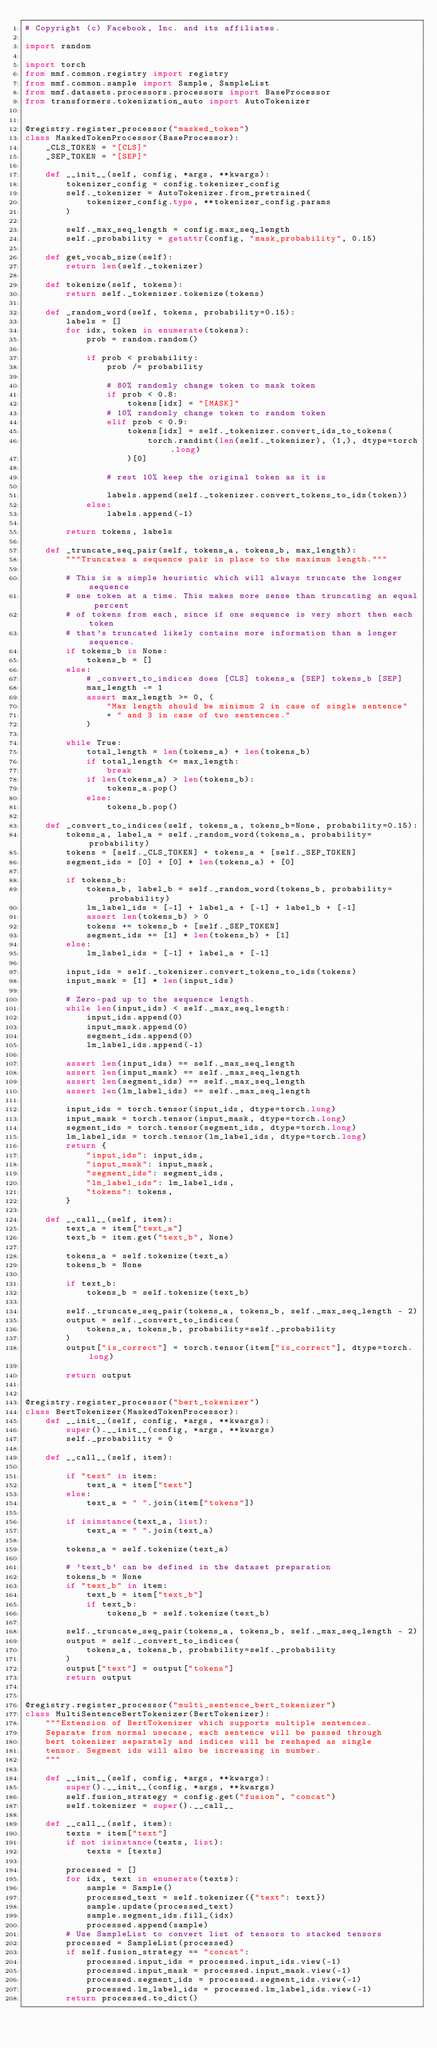<code> <loc_0><loc_0><loc_500><loc_500><_Python_># Copyright (c) Facebook, Inc. and its affiliates.

import random

import torch
from mmf.common.registry import registry
from mmf.common.sample import Sample, SampleList
from mmf.datasets.processors.processors import BaseProcessor
from transformers.tokenization_auto import AutoTokenizer


@registry.register_processor("masked_token")
class MaskedTokenProcessor(BaseProcessor):
    _CLS_TOKEN = "[CLS]"
    _SEP_TOKEN = "[SEP]"

    def __init__(self, config, *args, **kwargs):
        tokenizer_config = config.tokenizer_config
        self._tokenizer = AutoTokenizer.from_pretrained(
            tokenizer_config.type, **tokenizer_config.params
        )

        self._max_seq_length = config.max_seq_length
        self._probability = getattr(config, "mask_probability", 0.15)

    def get_vocab_size(self):
        return len(self._tokenizer)

    def tokenize(self, tokens):
        return self._tokenizer.tokenize(tokens)

    def _random_word(self, tokens, probability=0.15):
        labels = []
        for idx, token in enumerate(tokens):
            prob = random.random()

            if prob < probability:
                prob /= probability

                # 80% randomly change token to mask token
                if prob < 0.8:
                    tokens[idx] = "[MASK]"
                # 10% randomly change token to random token
                elif prob < 0.9:
                    tokens[idx] = self._tokenizer.convert_ids_to_tokens(
                        torch.randint(len(self._tokenizer), (1,), dtype=torch.long)
                    )[0]

                # rest 10% keep the original token as it is

                labels.append(self._tokenizer.convert_tokens_to_ids(token))
            else:
                labels.append(-1)

        return tokens, labels

    def _truncate_seq_pair(self, tokens_a, tokens_b, max_length):
        """Truncates a sequence pair in place to the maximum length."""

        # This is a simple heuristic which will always truncate the longer sequence
        # one token at a time. This makes more sense than truncating an equal percent
        # of tokens from each, since if one sequence is very short then each token
        # that's truncated likely contains more information than a longer sequence.
        if tokens_b is None:
            tokens_b = []
        else:
            # _convert_to_indices does [CLS] tokens_a [SEP] tokens_b [SEP]
            max_length -= 1
            assert max_length >= 0, (
                "Max length should be minimum 2 in case of single sentence"
                + " and 3 in case of two sentences."
            )

        while True:
            total_length = len(tokens_a) + len(tokens_b)
            if total_length <= max_length:
                break
            if len(tokens_a) > len(tokens_b):
                tokens_a.pop()
            else:
                tokens_b.pop()

    def _convert_to_indices(self, tokens_a, tokens_b=None, probability=0.15):
        tokens_a, label_a = self._random_word(tokens_a, probability=probability)
        tokens = [self._CLS_TOKEN] + tokens_a + [self._SEP_TOKEN]
        segment_ids = [0] + [0] * len(tokens_a) + [0]

        if tokens_b:
            tokens_b, label_b = self._random_word(tokens_b, probability=probability)
            lm_label_ids = [-1] + label_a + [-1] + label_b + [-1]
            assert len(tokens_b) > 0
            tokens += tokens_b + [self._SEP_TOKEN]
            segment_ids += [1] * len(tokens_b) + [1]
        else:
            lm_label_ids = [-1] + label_a + [-1]

        input_ids = self._tokenizer.convert_tokens_to_ids(tokens)
        input_mask = [1] * len(input_ids)

        # Zero-pad up to the sequence length.
        while len(input_ids) < self._max_seq_length:
            input_ids.append(0)
            input_mask.append(0)
            segment_ids.append(0)
            lm_label_ids.append(-1)

        assert len(input_ids) == self._max_seq_length
        assert len(input_mask) == self._max_seq_length
        assert len(segment_ids) == self._max_seq_length
        assert len(lm_label_ids) == self._max_seq_length

        input_ids = torch.tensor(input_ids, dtype=torch.long)
        input_mask = torch.tensor(input_mask, dtype=torch.long)
        segment_ids = torch.tensor(segment_ids, dtype=torch.long)
        lm_label_ids = torch.tensor(lm_label_ids, dtype=torch.long)
        return {
            "input_ids": input_ids,
            "input_mask": input_mask,
            "segment_ids": segment_ids,
            "lm_label_ids": lm_label_ids,
            "tokens": tokens,
        }

    def __call__(self, item):
        text_a = item["text_a"]
        text_b = item.get("text_b", None)

        tokens_a = self.tokenize(text_a)
        tokens_b = None

        if text_b:
            tokens_b = self.tokenize(text_b)

        self._truncate_seq_pair(tokens_a, tokens_b, self._max_seq_length - 2)
        output = self._convert_to_indices(
            tokens_a, tokens_b, probability=self._probability
        )
        output["is_correct"] = torch.tensor(item["is_correct"], dtype=torch.long)

        return output


@registry.register_processor("bert_tokenizer")
class BertTokenizer(MaskedTokenProcessor):
    def __init__(self, config, *args, **kwargs):
        super().__init__(config, *args, **kwargs)
        self._probability = 0

    def __call__(self, item):

        if "text" in item:
            text_a = item["text"]
        else:
            text_a = " ".join(item["tokens"])

        if isinstance(text_a, list):
            text_a = " ".join(text_a)

        tokens_a = self.tokenize(text_a)

        # 'text_b' can be defined in the dataset preparation
        tokens_b = None
        if "text_b" in item:
            text_b = item["text_b"]
            if text_b:
                tokens_b = self.tokenize(text_b)

        self._truncate_seq_pair(tokens_a, tokens_b, self._max_seq_length - 2)
        output = self._convert_to_indices(
            tokens_a, tokens_b, probability=self._probability
        )
        output["text"] = output["tokens"]
        return output


@registry.register_processor("multi_sentence_bert_tokenizer")
class MultiSentenceBertTokenizer(BertTokenizer):
    """Extension of BertTokenizer which supports multiple sentences.
    Separate from normal usecase, each sentence will be passed through
    bert tokenizer separately and indices will be reshaped as single
    tensor. Segment ids will also be increasing in number.
    """

    def __init__(self, config, *args, **kwargs):
        super().__init__(config, *args, **kwargs)
        self.fusion_strategy = config.get("fusion", "concat")
        self.tokenizer = super().__call__

    def __call__(self, item):
        texts = item["text"]
        if not isinstance(texts, list):
            texts = [texts]

        processed = []
        for idx, text in enumerate(texts):
            sample = Sample()
            processed_text = self.tokenizer({"text": text})
            sample.update(processed_text)
            sample.segment_ids.fill_(idx)
            processed.append(sample)
        # Use SampleList to convert list of tensors to stacked tensors
        processed = SampleList(processed)
        if self.fusion_strategy == "concat":
            processed.input_ids = processed.input_ids.view(-1)
            processed.input_mask = processed.input_mask.view(-1)
            processed.segment_ids = processed.segment_ids.view(-1)
            processed.lm_label_ids = processed.lm_label_ids.view(-1)
        return processed.to_dict()
</code> 